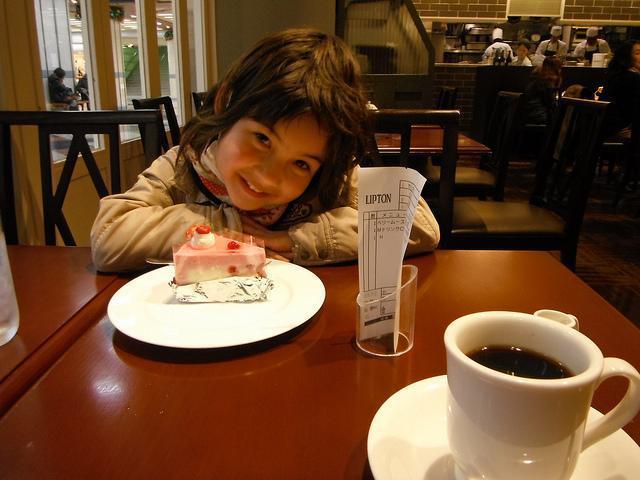How many dining tables are in the photo?
Give a very brief answer. 2. How many chairs can be seen?
Give a very brief answer. 4. How many people are there?
Give a very brief answer. 2. 